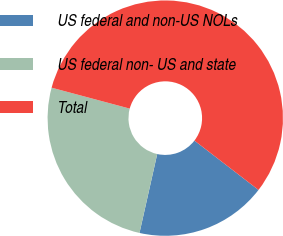Convert chart. <chart><loc_0><loc_0><loc_500><loc_500><pie_chart><fcel>US federal and non-US NOLs<fcel>US federal non- US and state<fcel>Total<nl><fcel>18.07%<fcel>25.65%<fcel>56.28%<nl></chart> 